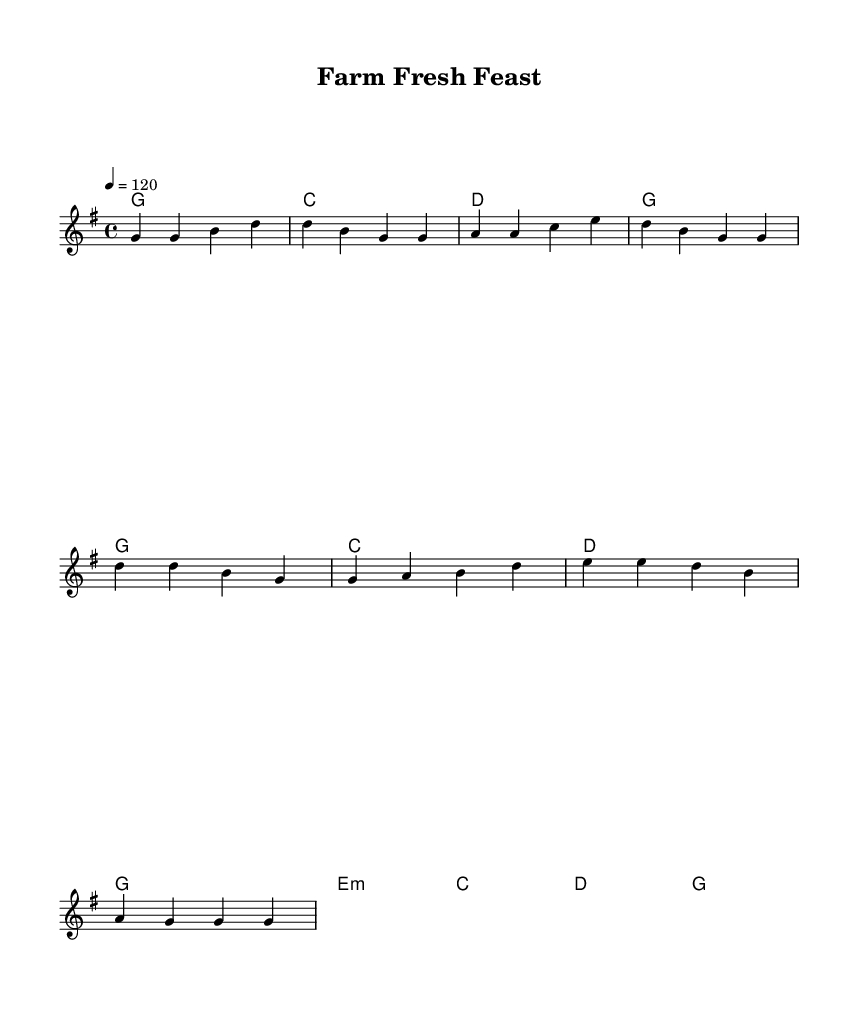What is the key signature of this music? The key signature is indicated at the start of the music and shows one sharp, which designates the key of G major.
Answer: G major What is the time signature of this music? The time signature, shown at the beginning of the staff, is 4/4, meaning there are four beats in each measure and a quarter note gets one beat.
Answer: 4/4 What is the tempo marking for this piece? The tempo marking is noted as '4 = 120', which indicates that there are 120 beats per minute, with a quarter note receiving one beat.
Answer: 120 How many measures are in the verse? By counting the measures in the melody section labeled "Verse," there are four distinct measures.
Answer: 4 What is the first word of the chorus? The lyrics for the chorus start with the word "Farm," which is the first word listed under the "Chorus" section.
Answer: Farm How do the verses relate to the chorus in content? The verses describe the journey of local farmers bringing fresh ingredients, while the chorus emphasizes the farm-to-table concept, connecting the two themes of freshness and local sourcing.
Answer: Farm-to-table concept What type of ingredients does the song emphasize? The song focuses on "fresh ingredients," indicating a preference for locally sourced and seasonal items that enhance the dining experience.
Answer: Fresh ingredients 